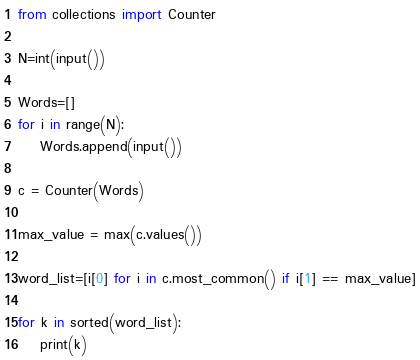<code> <loc_0><loc_0><loc_500><loc_500><_Python_>from collections import Counter

N=int(input())

Words=[]
for i in range(N):
    Words.append(input())

c = Counter(Words)

max_value = max(c.values())

word_list=[i[0] for i in c.most_common() if i[1] == max_value]

for k in sorted(word_list):
    print(k)</code> 